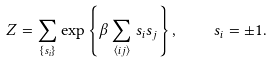<formula> <loc_0><loc_0><loc_500><loc_500>Z = \sum _ { \{ s _ { i } \} } \exp \left \{ \beta \sum _ { \langle i j \rangle } s _ { i } s _ { j } \right \} , \quad s _ { i } = \pm 1 .</formula> 